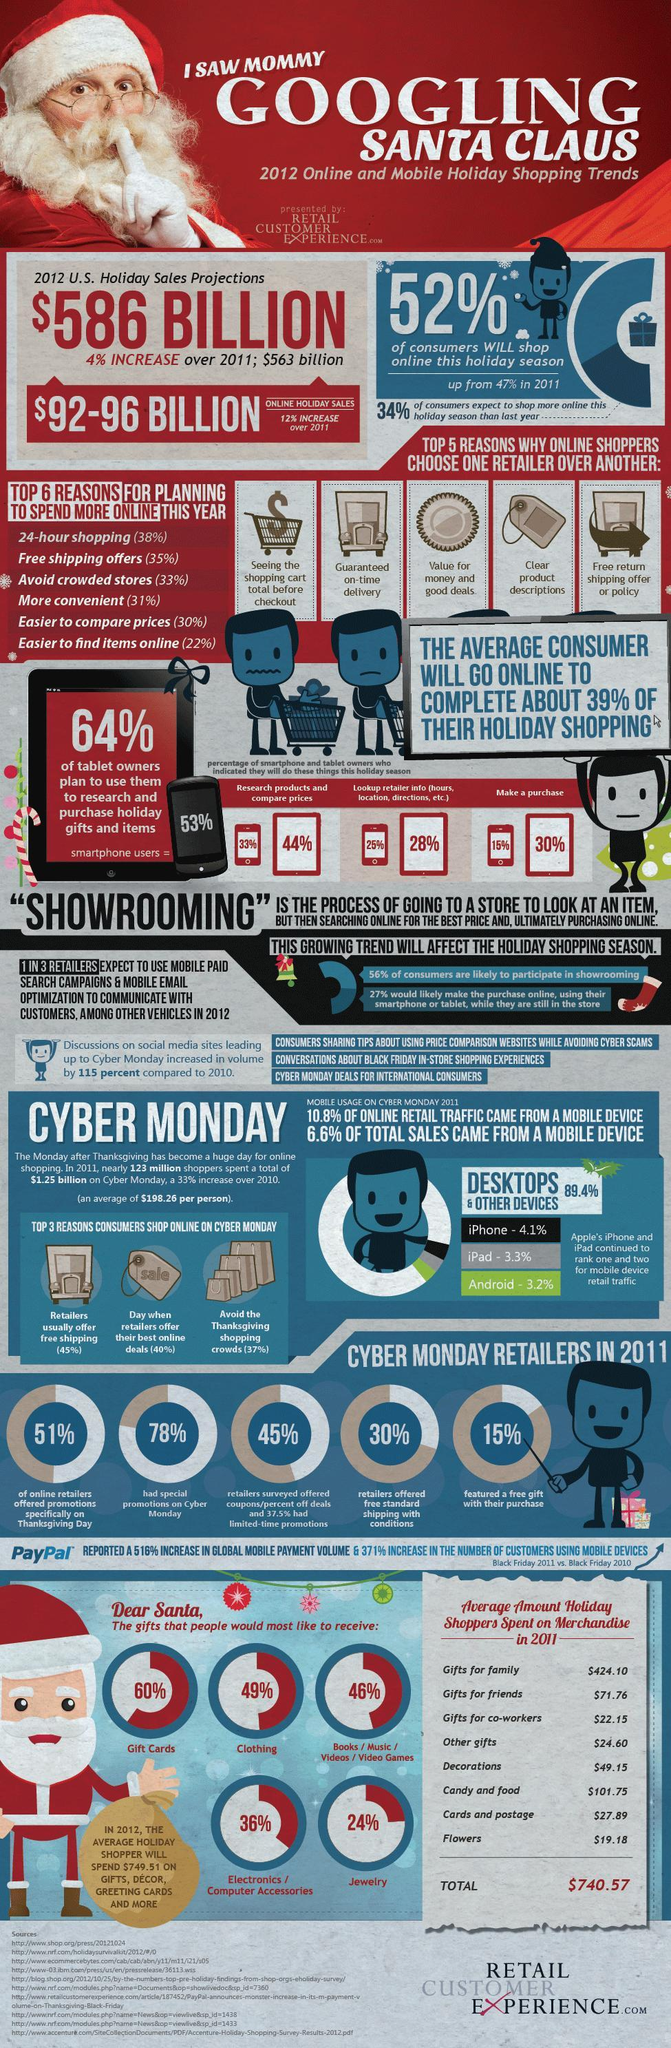What percentage of people use tablets to research products and compare prices?
Answer the question with a short phrase. 44% What percentage of people will not shop online in 2012 holiday season? 48 What percentage of tablet owners check retailer information in it? 28% What percentage of smart phone users research and purchase gifts, items online? 53% What percentage of retailers had special promotions on Cyber Monday? 78% What percentage of smart phone users checks retailer information in it? 25% What percentage of retailers offered free shipping on Cyber Monday? 30% Which device got the third rank for mobile device retail traffic? Android What percentage of smart phone users make a purchase in this holiday season? 15% What percentage of tablet owners do not make a purchase in this holiday season? 70 